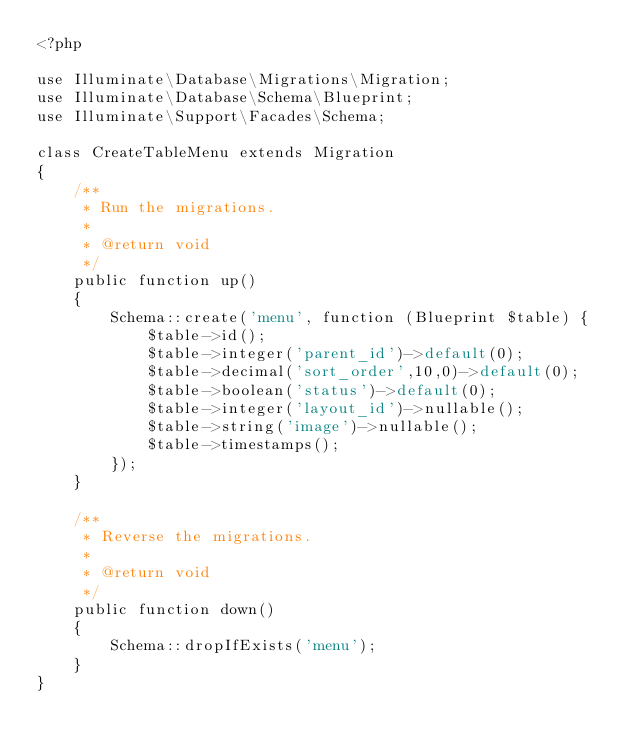<code> <loc_0><loc_0><loc_500><loc_500><_PHP_><?php

use Illuminate\Database\Migrations\Migration;
use Illuminate\Database\Schema\Blueprint;
use Illuminate\Support\Facades\Schema;

class CreateTableMenu extends Migration
{
    /**
     * Run the migrations.
     *
     * @return void
     */
    public function up()
    {
        Schema::create('menu', function (Blueprint $table) {
            $table->id();
            $table->integer('parent_id')->default(0);
            $table->decimal('sort_order',10,0)->default(0);
            $table->boolean('status')->default(0);
            $table->integer('layout_id')->nullable();
            $table->string('image')->nullable();
            $table->timestamps();
        });
    }

    /**
     * Reverse the migrations.
     *
     * @return void
     */
    public function down()
    {
        Schema::dropIfExists('menu');
    }
}
</code> 